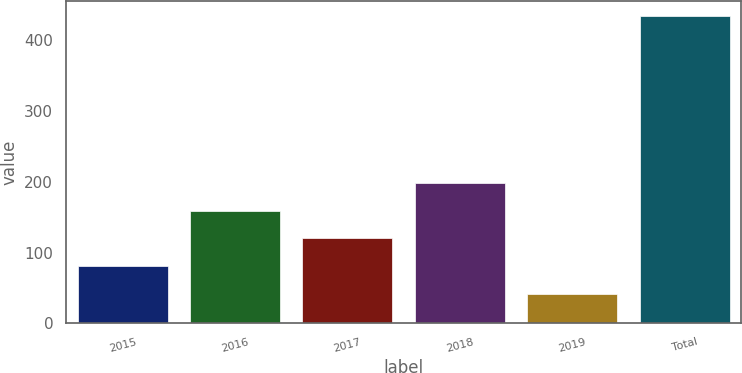<chart> <loc_0><loc_0><loc_500><loc_500><bar_chart><fcel>2015<fcel>2016<fcel>2017<fcel>2018<fcel>2019<fcel>Total<nl><fcel>81.2<fcel>159.6<fcel>120.4<fcel>198.8<fcel>42<fcel>434<nl></chart> 